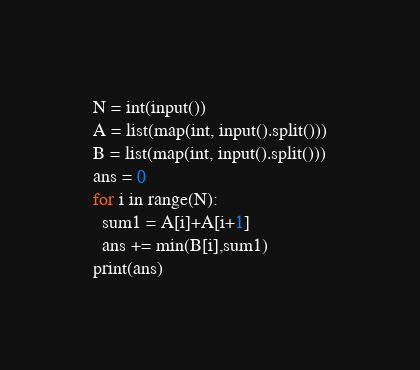<code> <loc_0><loc_0><loc_500><loc_500><_Python_>N = int(input())
A = list(map(int, input().split()))
B = list(map(int, input().split()))
ans = 0
for i in range(N):
  sum1 = A[i]+A[i+1]
  ans += min(B[i],sum1)
print(ans)  </code> 